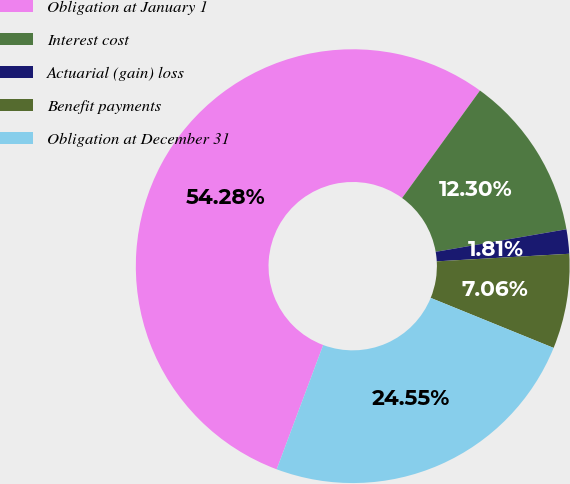Convert chart. <chart><loc_0><loc_0><loc_500><loc_500><pie_chart><fcel>Obligation at January 1<fcel>Interest cost<fcel>Actuarial (gain) loss<fcel>Benefit payments<fcel>Obligation at December 31<nl><fcel>54.28%<fcel>12.3%<fcel>1.81%<fcel>7.06%<fcel>24.55%<nl></chart> 